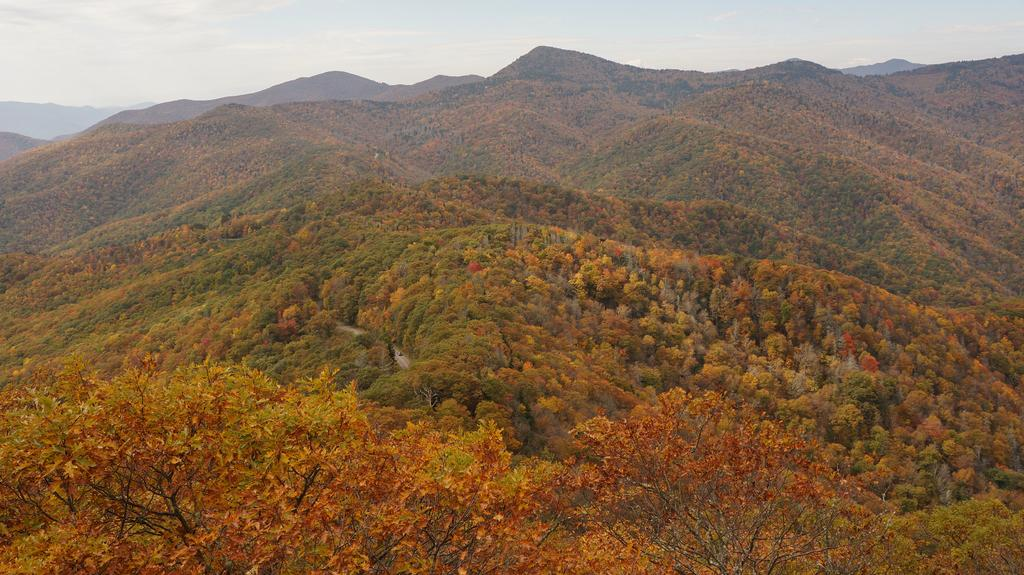What type of vegetation can be seen in the image? There are trees in the image. What type of landscape feature is present in the image? There are hills in the image. What is visible at the top of the image? The sky is visible at the top of the image. What type of jam is spread on the hills in the image? There is no jam present in the image; it features trees and hills. What impulse might have caused the trees to grow in such a pattern in the image? The image does not provide information about the impulses that caused the trees to grow in a specific pattern. 